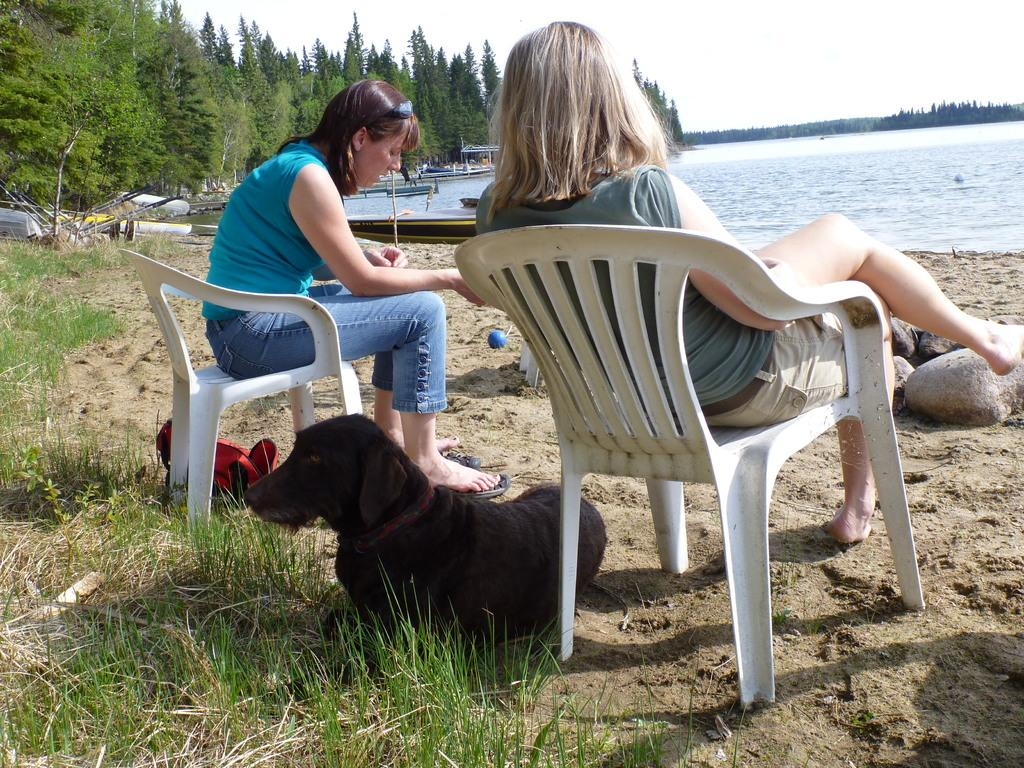How many women are in the image? There are two women in the image. What are the women doing in the image? The women are sitting on a chair. Where is the chair located in the image? The chair is in front of a lake. What other animal is present in the image? There is a dog in the image. What is the color of the dog? The dog is black in color. What type of vegetation can be seen in the image? There are trees visible in the image. What type of nerve can be seen in the image? There is no nerve present in the image. How many cattle are visible in the image? There are no cattle present in the image. 